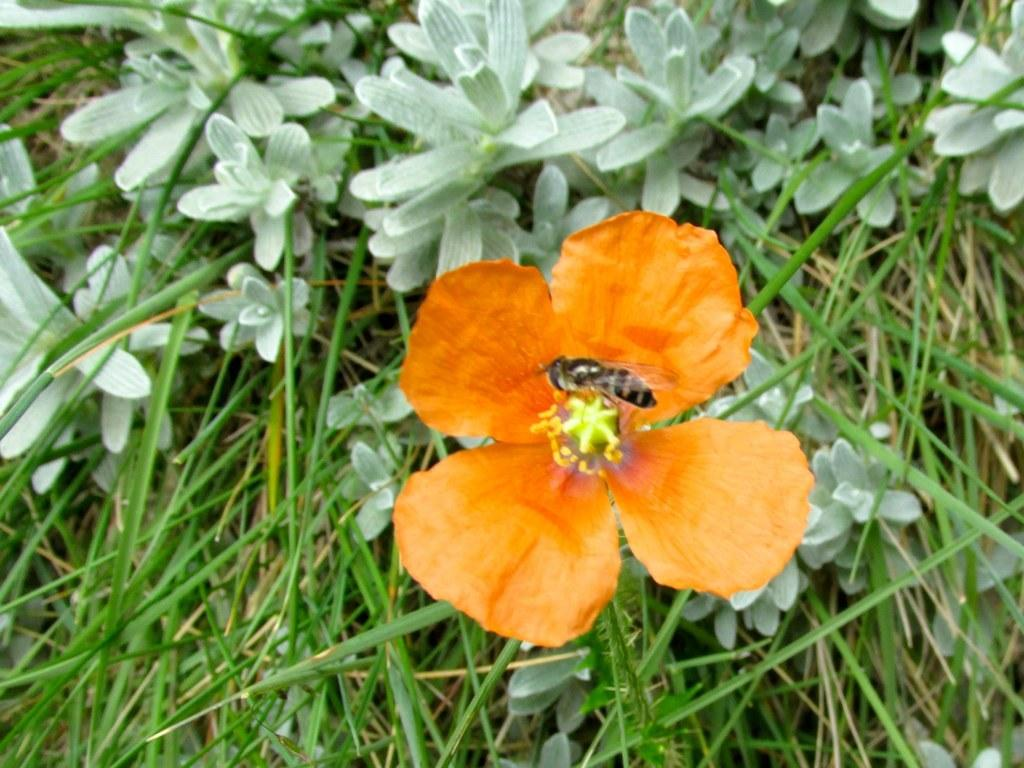What type of plant is visible in the image? There is a flower in the image. Are there any other plants visible in the image? Yes, there are plants in the image. What type of vegetation is present in the image? There is grass in the image. What causes the powder to spread in the image? There is no powder present in the image, so it cannot be determined what might cause it to spread. 